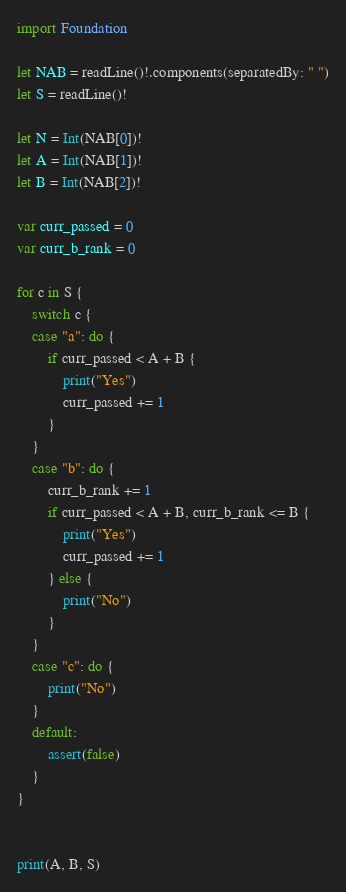Convert code to text. <code><loc_0><loc_0><loc_500><loc_500><_Swift_>import Foundation

let NAB = readLine()!.components(separatedBy: " ")
let S = readLine()!

let N = Int(NAB[0])!
let A = Int(NAB[1])!
let B = Int(NAB[2])!

var curr_passed = 0
var curr_b_rank = 0

for c in S {
    switch c {
    case "a": do {
        if curr_passed < A + B {
            print("Yes")
            curr_passed += 1
        }
    }
    case "b": do {
        curr_b_rank += 1
        if curr_passed < A + B, curr_b_rank <= B {
            print("Yes")
            curr_passed += 1
        } else {
            print("No")
        }
    }
    case "c": do {
        print("No")
    }
    default:
        assert(false)
    }
}


print(A, B, S)</code> 